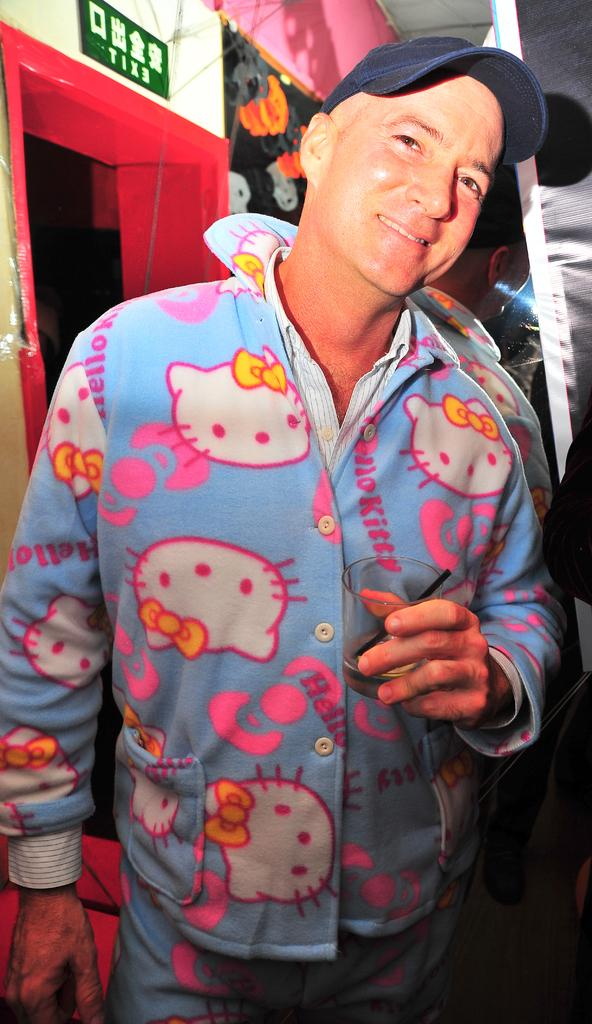Who is present in the image? There is a man in the image. What is the man wearing on his head? The man is wearing a blue cap. What can be seen in the background of the image? There is a wall in the background of the image. What is on the wall? The wall has a green color board on it. What architectural feature is visible on the left side of the image? There appears to be a door on the left side of the image. What flavor of sponge is the man holding in the image? There is no sponge present in the image, and therefore no flavor can be determined. 